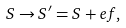Convert formula to latex. <formula><loc_0><loc_0><loc_500><loc_500>S \to S ^ { \prime } = S + e f ,</formula> 